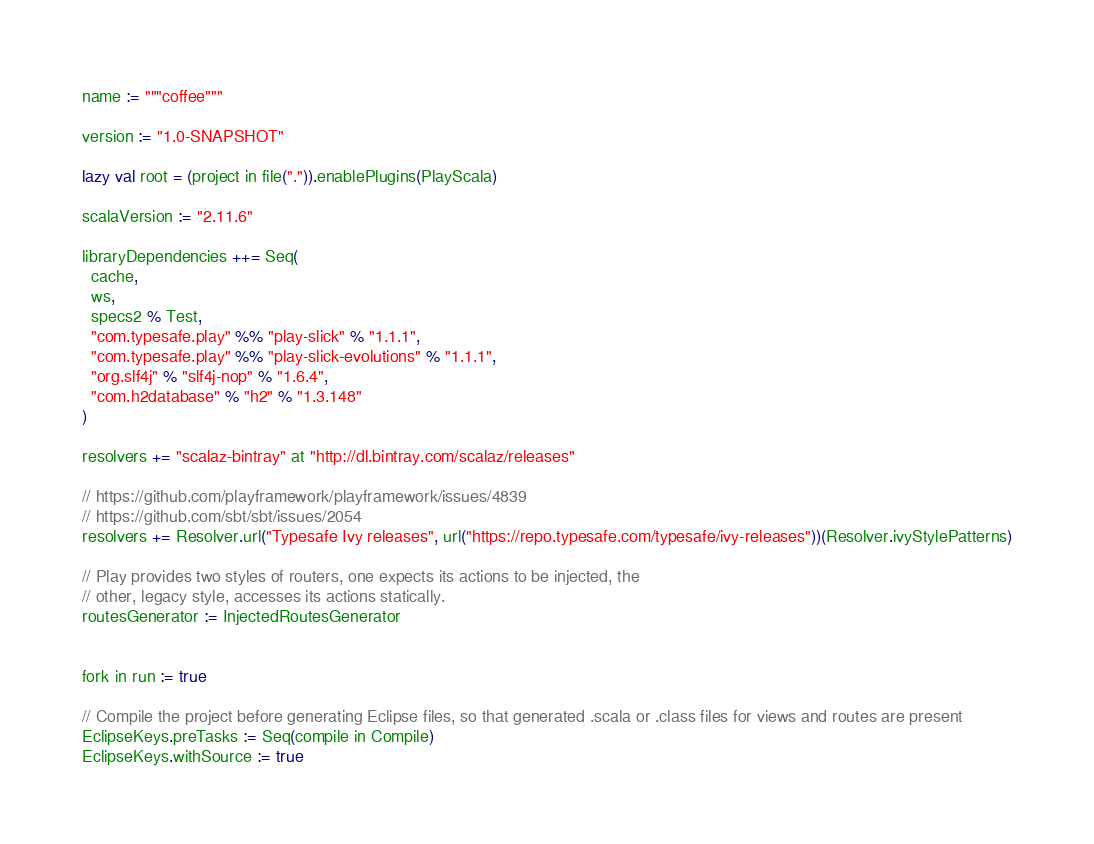Convert code to text. <code><loc_0><loc_0><loc_500><loc_500><_Scala_>name := """coffee"""

version := "1.0-SNAPSHOT"

lazy val root = (project in file(".")).enablePlugins(PlayScala)

scalaVersion := "2.11.6"

libraryDependencies ++= Seq(
  cache,
  ws,
  specs2 % Test,
  "com.typesafe.play" %% "play-slick" % "1.1.1",
  "com.typesafe.play" %% "play-slick-evolutions" % "1.1.1",
  "org.slf4j" % "slf4j-nop" % "1.6.4",
  "com.h2database" % "h2" % "1.3.148"
)

resolvers += "scalaz-bintray" at "http://dl.bintray.com/scalaz/releases"

// https://github.com/playframework/playframework/issues/4839
// https://github.com/sbt/sbt/issues/2054
resolvers += Resolver.url("Typesafe Ivy releases", url("https://repo.typesafe.com/typesafe/ivy-releases"))(Resolver.ivyStylePatterns)

// Play provides two styles of routers, one expects its actions to be injected, the
// other, legacy style, accesses its actions statically.
routesGenerator := InjectedRoutesGenerator


fork in run := true

// Compile the project before generating Eclipse files, so that generated .scala or .class files for views and routes are present
EclipseKeys.preTasks := Seq(compile in Compile)
EclipseKeys.withSource := true
</code> 